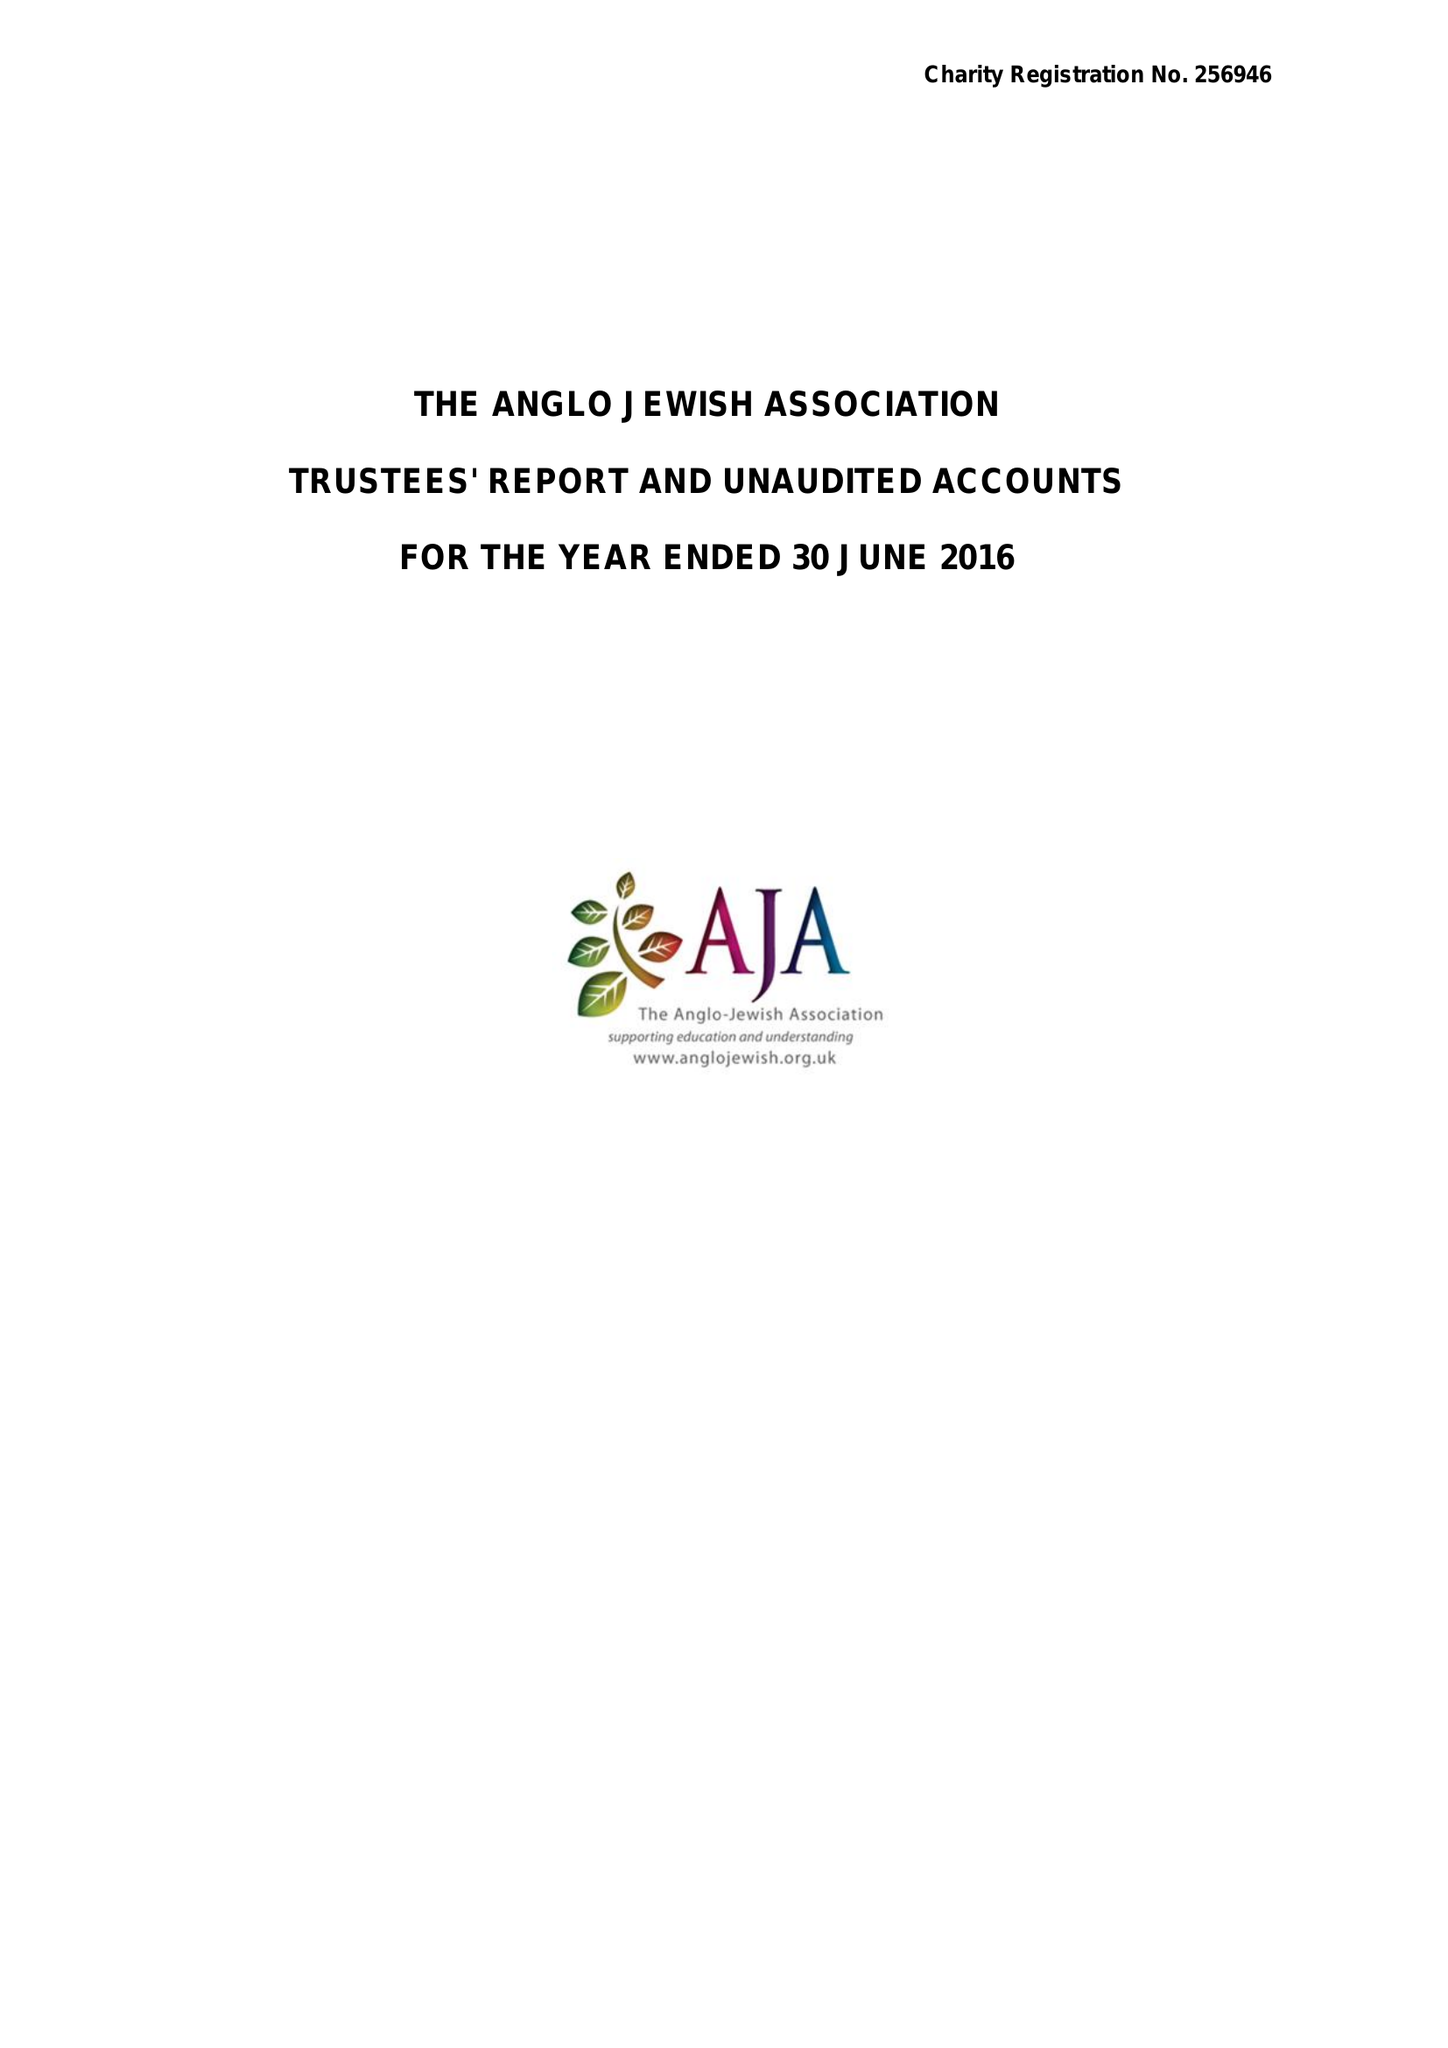What is the value for the charity_number?
Answer the question using a single word or phrase. 256946 